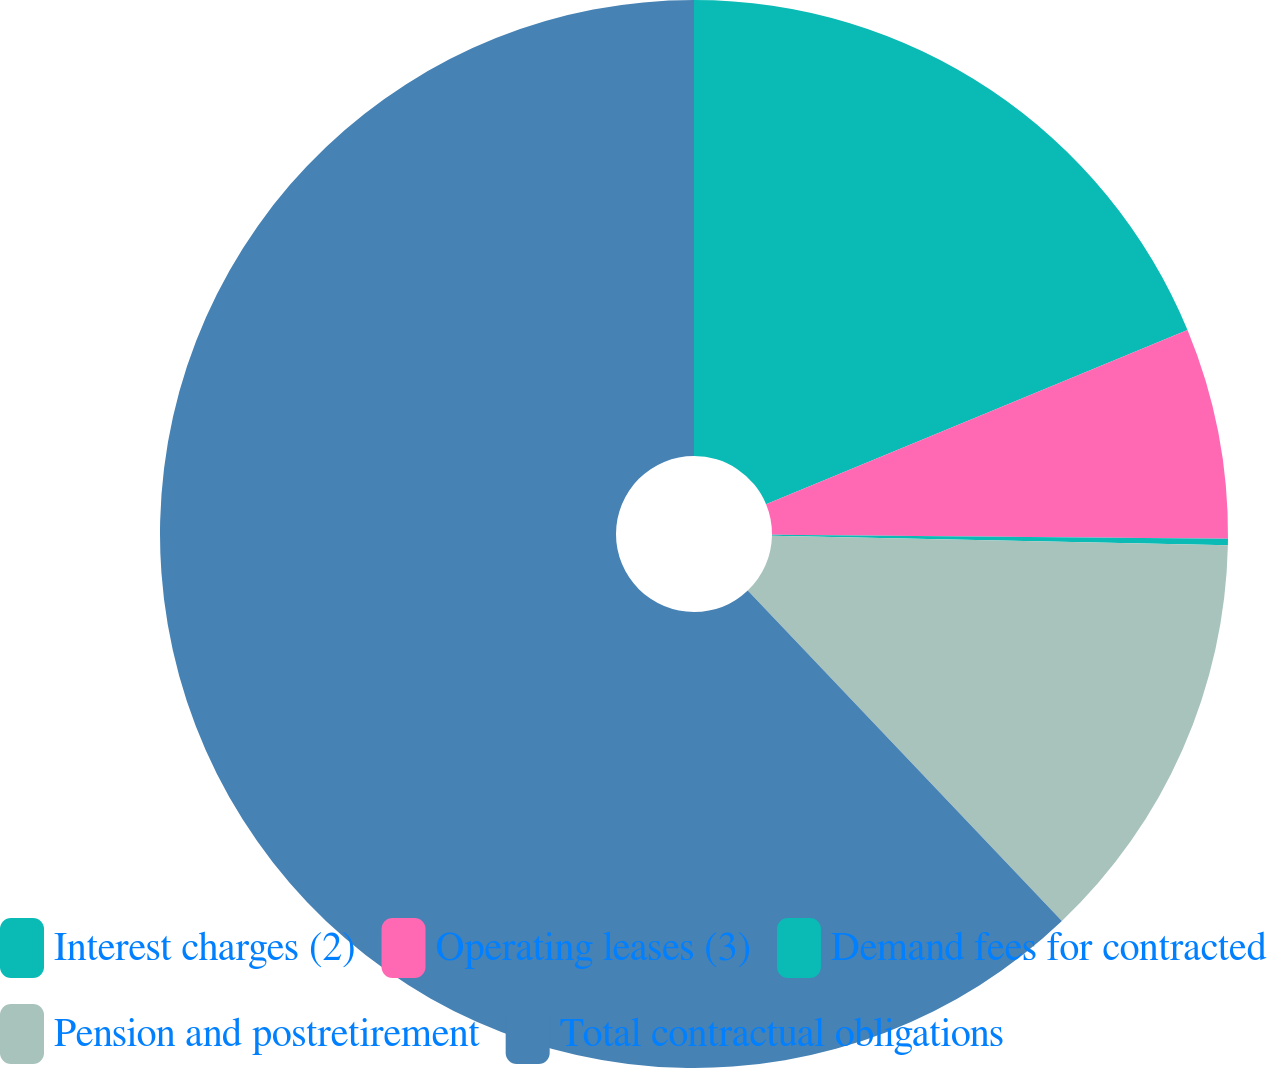Convert chart to OTSL. <chart><loc_0><loc_0><loc_500><loc_500><pie_chart><fcel>Interest charges (2)<fcel>Operating leases (3)<fcel>Demand fees for contracted<fcel>Pension and postretirement<fcel>Total contractual obligations<nl><fcel>18.76%<fcel>6.38%<fcel>0.19%<fcel>12.57%<fcel>62.09%<nl></chart> 